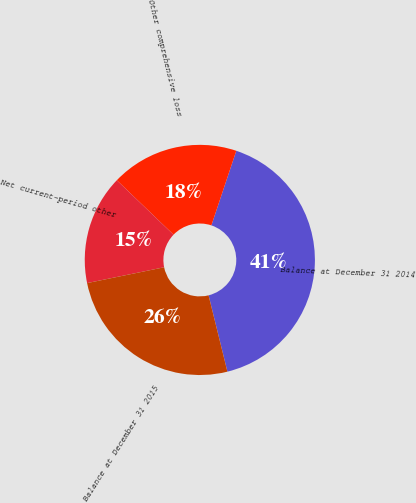<chart> <loc_0><loc_0><loc_500><loc_500><pie_chart><fcel>Balance at December 31 2014<fcel>Other comprehensive loss<fcel>Net current-period other<fcel>Balance at December 31 2015<nl><fcel>41.02%<fcel>17.96%<fcel>15.4%<fcel>25.63%<nl></chart> 